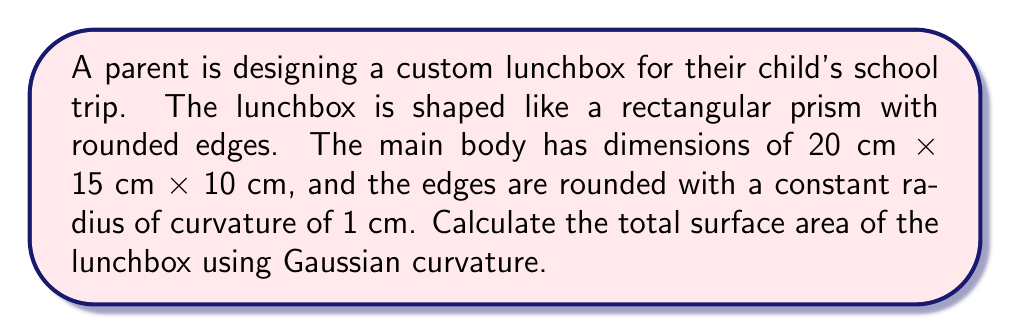Teach me how to tackle this problem. Let's approach this step-by-step:

1) First, we need to understand that the lunchbox consists of flat surfaces (the faces) and curved surfaces (the rounded edges).

2) For the flat surfaces, the Gaussian curvature K = 0. The area of these surfaces is simply their length times width.

3) For the curved edges, we need to use the Gaussian curvature. For a cylinder (which our rounded edges approximate), K = 0 along the length, and K = 1/r^2 at the corners, where r is the radius of curvature.

4) The surface area of the flat parts:
   - Top and bottom: 2 × (20 cm × 15 cm) = 600 cm²
   - Front and back: 2 × (20 cm × 10 cm) = 400 cm²
   - Sides: 2 × (15 cm × 10 cm) = 300 cm²
   Total flat surface area = 1300 cm²

5) For the rounded edges:
   - We have 12 edges, each with length either 20 cm, 15 cm, or 10 cm
   - The surface area of a rounded edge is approximately its length times π * r
   - Total length of edges: 4 × (20 + 15 + 10) = 180 cm
   - Surface area of rounded edges: 180 cm × π × 1 cm ≈ 565.49 cm²

6) For the corners, we need to subtract the overlapping areas:
   - There are 8 corners
   - Each corner is approximately a eighth of a sphere with radius 1 cm
   - Surface area of a sphere is 4πr²
   - Area to subtract: 8 × (1/8 × 4π × 1²) = 4π cm² ≈ 12.57 cm²

7) Total surface area:
   Flat surfaces + Rounded edges - Corner overlaps
   = 1300 cm² + 565.49 cm² - 12.57 cm²
   ≈ 1852.92 cm²
Answer: $$1852.92 \text{ cm}^2$$ 